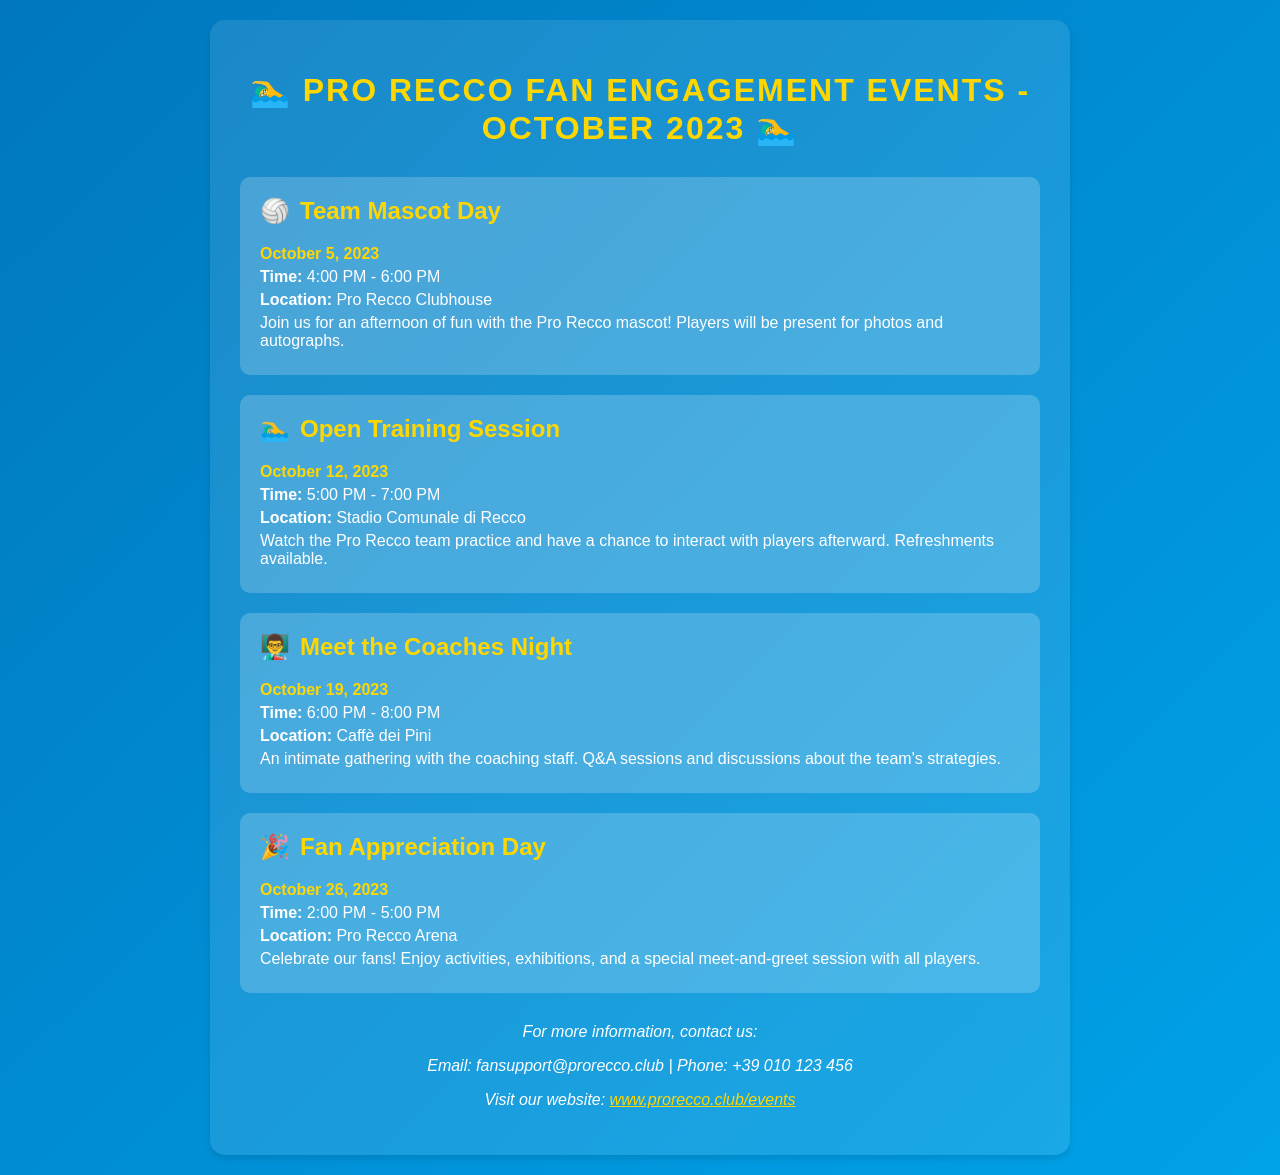What is the date of Team Mascot Day? The date for Team Mascot Day is explicitly provided in the document.
Answer: October 5, 2023 When is the Open Training Session scheduled? The schedule lists the date and time for the Open Training Session clearly.
Answer: October 12, 2023 What time does the Meet the Coaches Night start? The document specifies the starting time for the Meet the Coaches Night event.
Answer: 6:00 PM Where will Fan Appreciation Day take place? The location for Fan Appreciation Day is mentioned in the schedule.
Answer: Pro Recco Arena How long is the Team Mascot Day event? The duration of the Team Mascot Day is listed in the schedule.
Answer: 2 hours What type of event is held on October 19, 2023? This question requires reasoning through the dates to identify the event type scheduled.
Answer: Meet the Coaches Night Which event includes activities and exhibitions? The document indicates the activities included in the Fan Appreciation Day event.
Answer: Fan Appreciation Day What is the email contact for fan support? The email address for fan support is provided at the end of the document.
Answer: fansupport@prorecco.club 